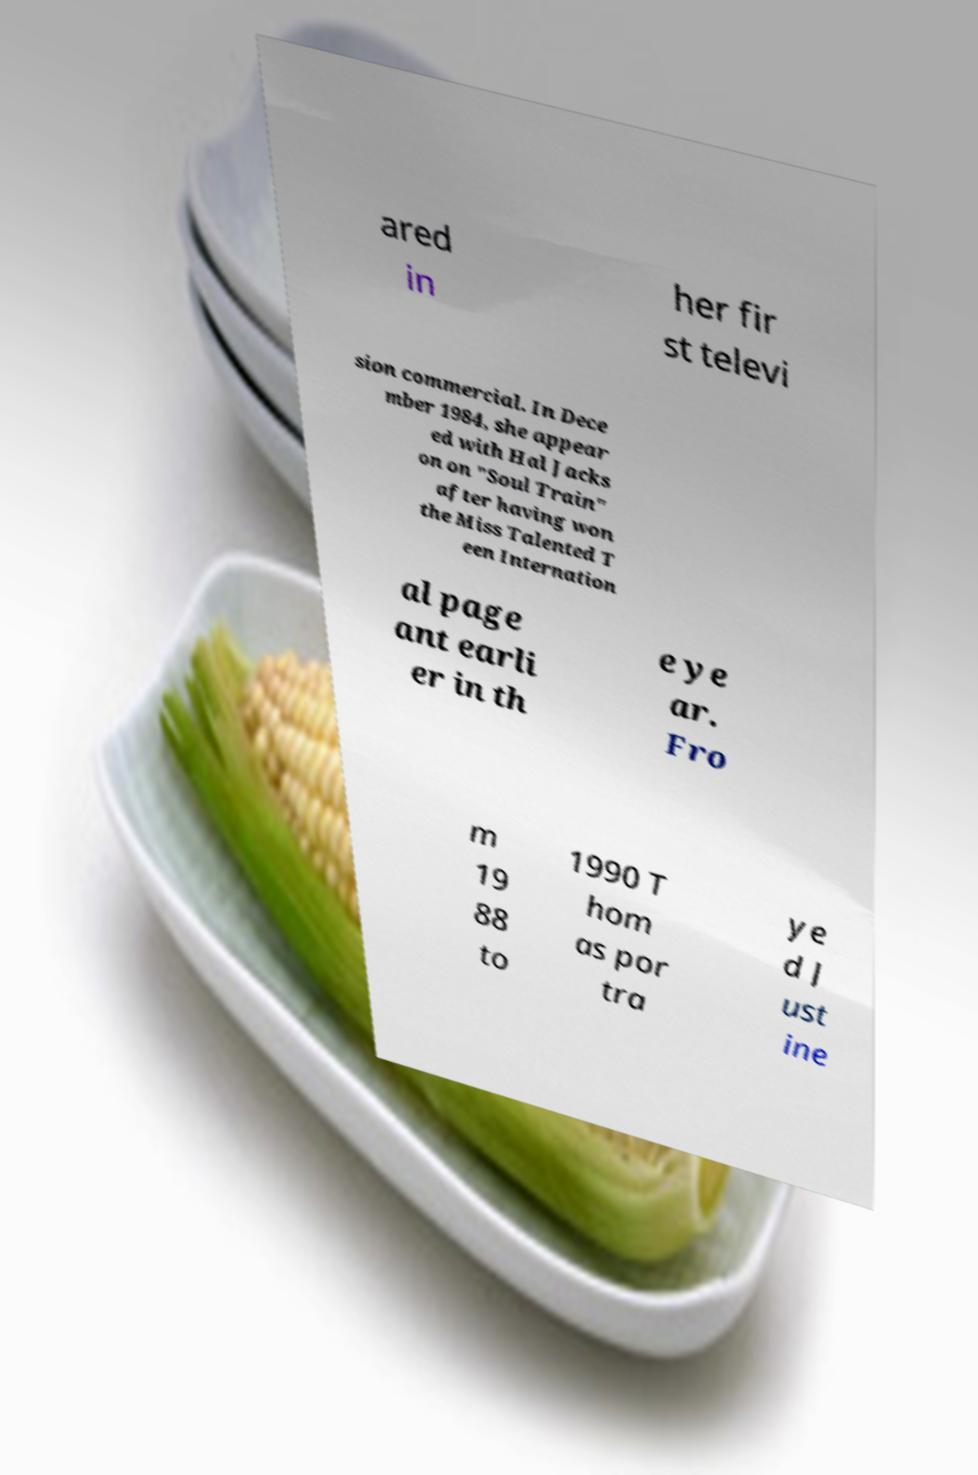For documentation purposes, I need the text within this image transcribed. Could you provide that? ared in her fir st televi sion commercial. In Dece mber 1984, she appear ed with Hal Jacks on on "Soul Train" after having won the Miss Talented T een Internation al page ant earli er in th e ye ar. Fro m 19 88 to 1990 T hom as por tra ye d J ust ine 